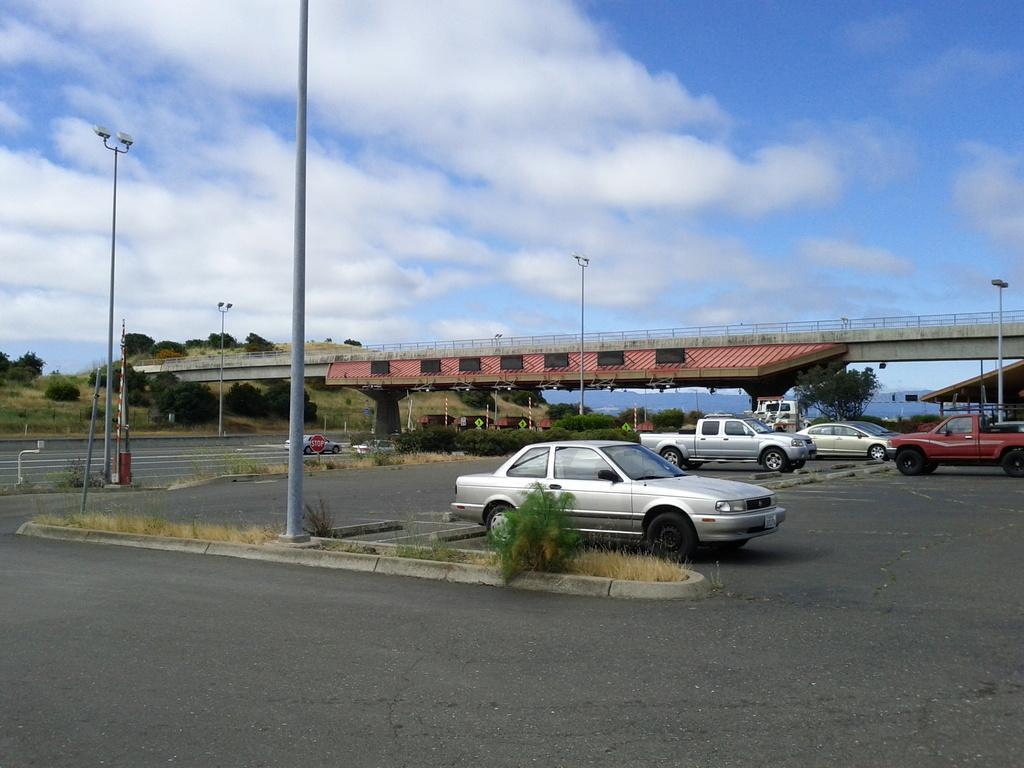Can you describe this image briefly? in this image we can see sky with clouds, street poles, street lights, road, pavement, grass, plants, trees, vehicles, foot over bridge and a sign board. 